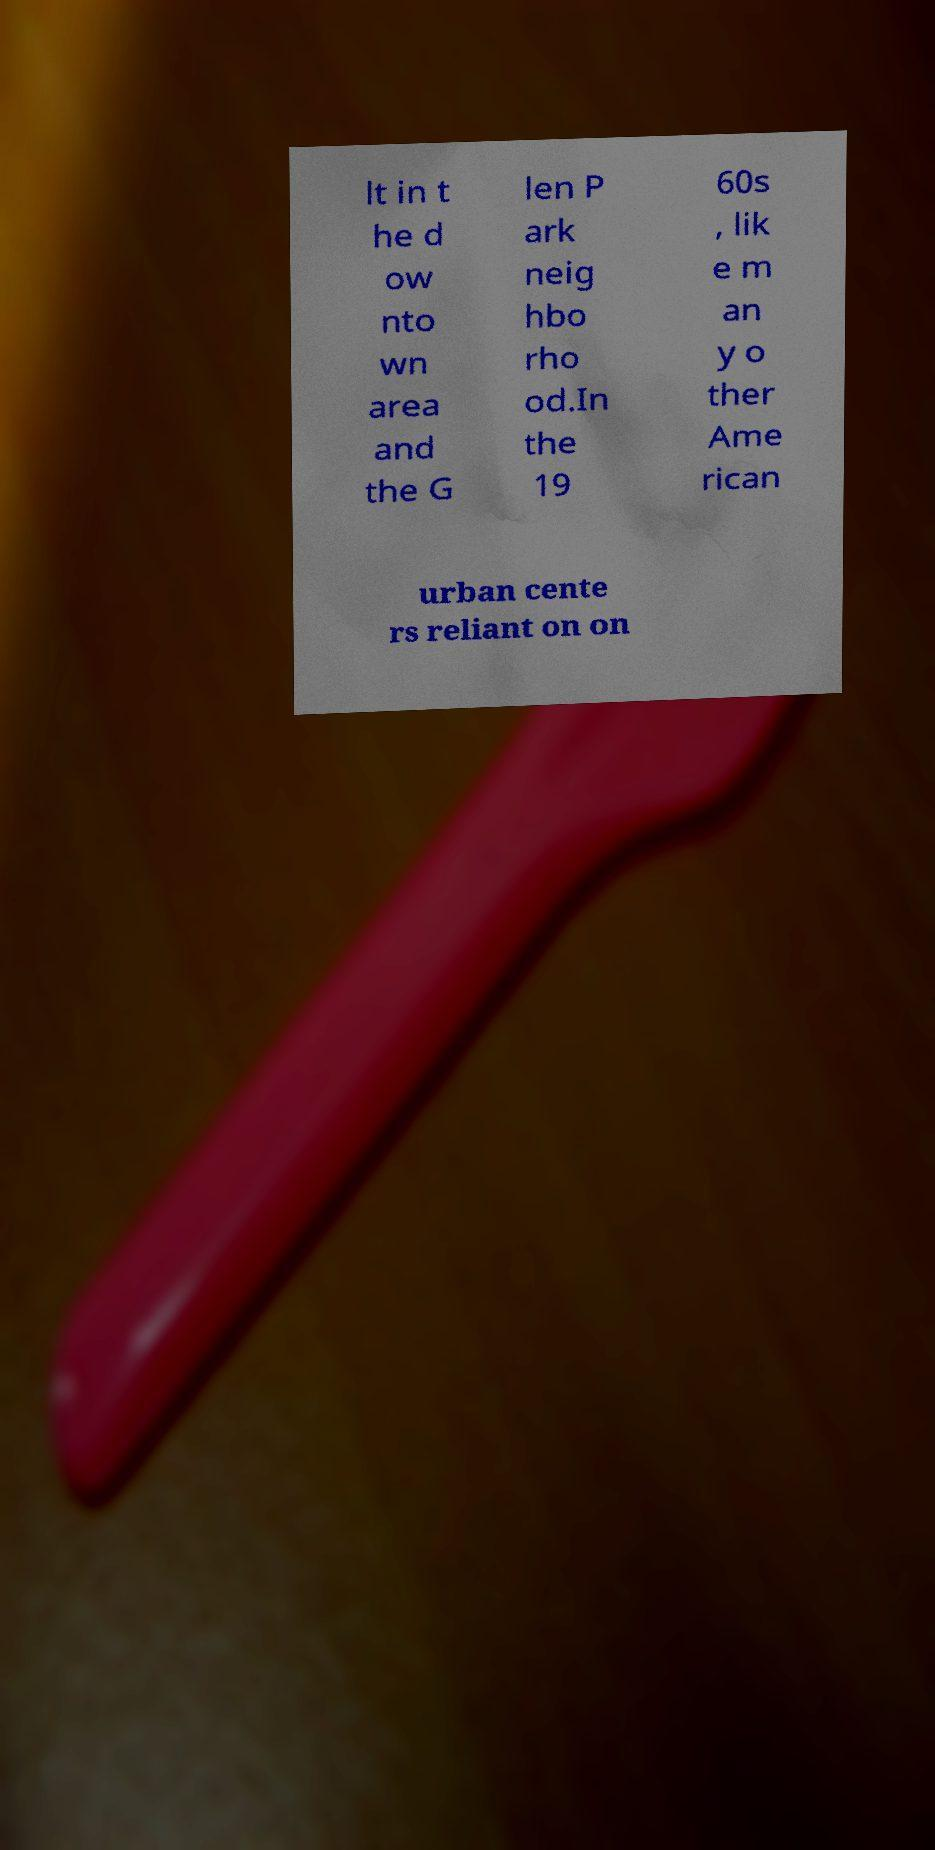Can you read and provide the text displayed in the image?This photo seems to have some interesting text. Can you extract and type it out for me? lt in t he d ow nto wn area and the G len P ark neig hbo rho od.In the 19 60s , lik e m an y o ther Ame rican urban cente rs reliant on on 